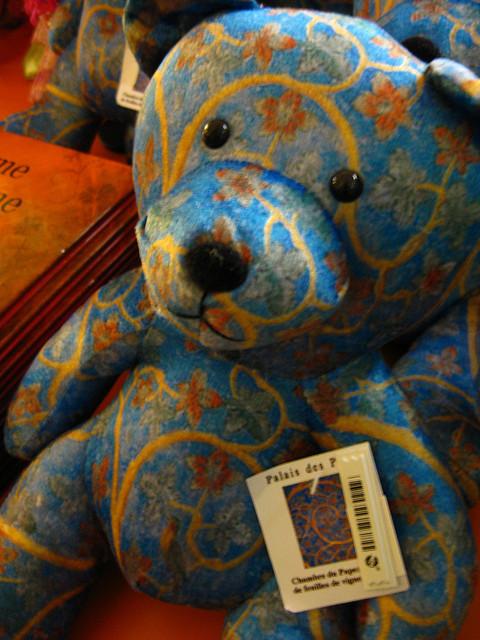Is there a price tag on the bear?
Write a very short answer. Yes. Is this a real bear?
Concise answer only. No. Is the teddy bear for sale?
Short answer required. Yes. 